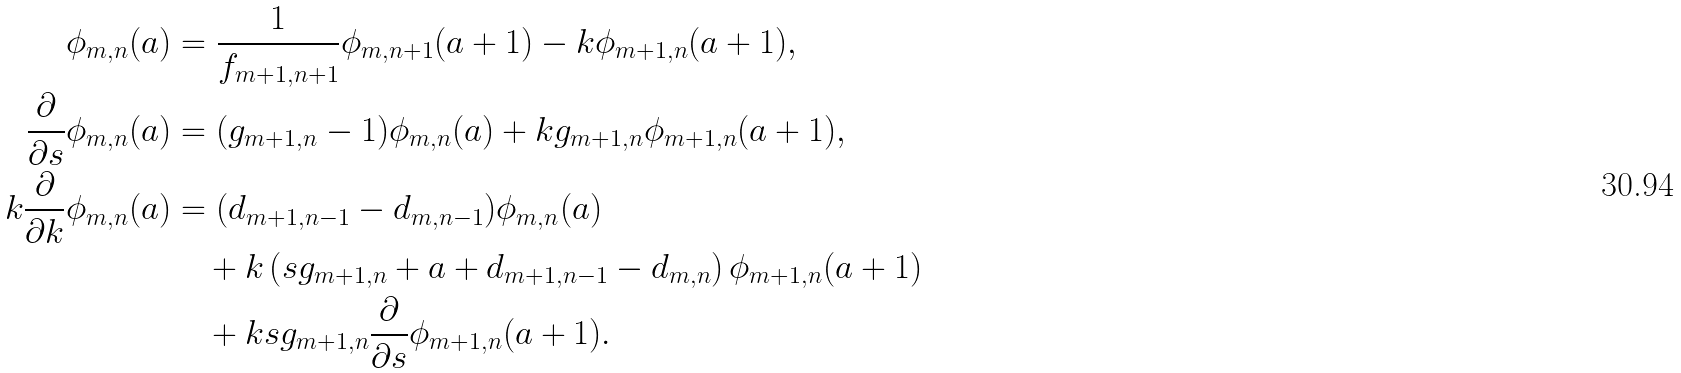<formula> <loc_0><loc_0><loc_500><loc_500>\phi _ { m , n } ( a ) & = \frac { 1 } { f _ { m + 1 , n + 1 } } \phi _ { m , n + 1 } ( a + 1 ) - k \phi _ { m + 1 , n } ( a + 1 ) , \\ \frac { \partial } { \partial s } \phi _ { m , n } ( a ) & = ( g _ { m + 1 , n } - 1 ) \phi _ { m , n } ( a ) + k g _ { m + 1 , n } \phi _ { m + 1 , n } ( a + 1 ) , \\ k \frac { \partial } { \partial k } \phi _ { m , n } ( a ) & = ( d _ { m + 1 , n - 1 } - d _ { m , n - 1 } ) \phi _ { m , n } ( a ) \\ & \quad + k \left ( s g _ { m + 1 , n } + a + d _ { m + 1 , n - 1 } - d _ { m , n } \right ) \phi _ { m + 1 , n } ( a + 1 ) \\ & \quad + k s g _ { m + 1 , n } \frac { \partial } { \partial s } \phi _ { m + 1 , n } ( a + 1 ) .</formula> 